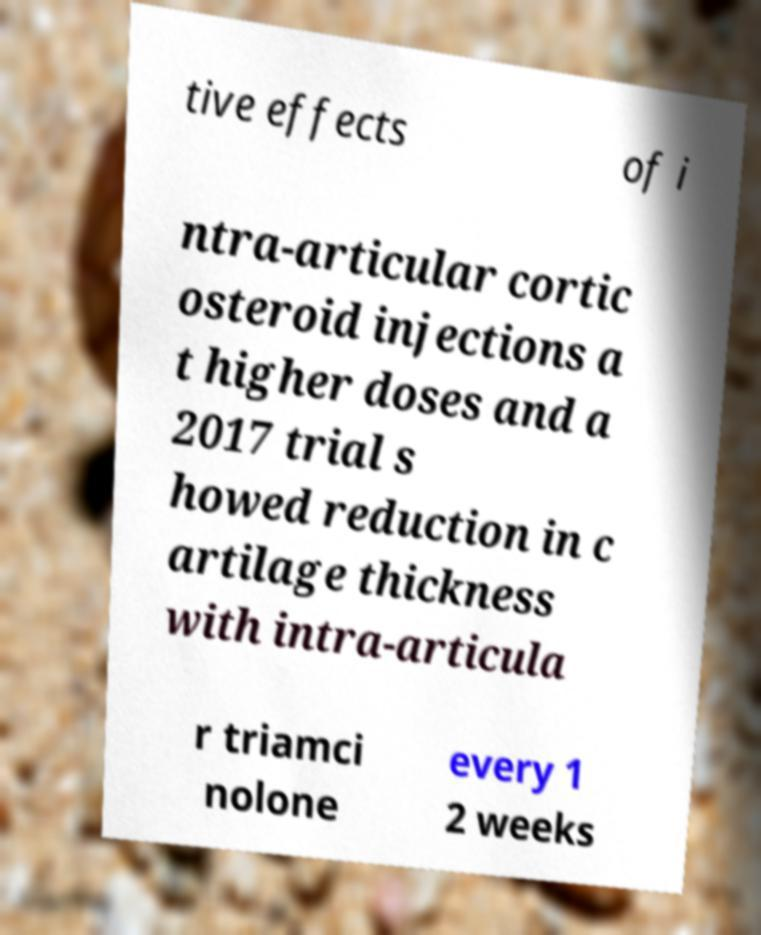Could you extract and type out the text from this image? tive effects of i ntra-articular cortic osteroid injections a t higher doses and a 2017 trial s howed reduction in c artilage thickness with intra-articula r triamci nolone every 1 2 weeks 